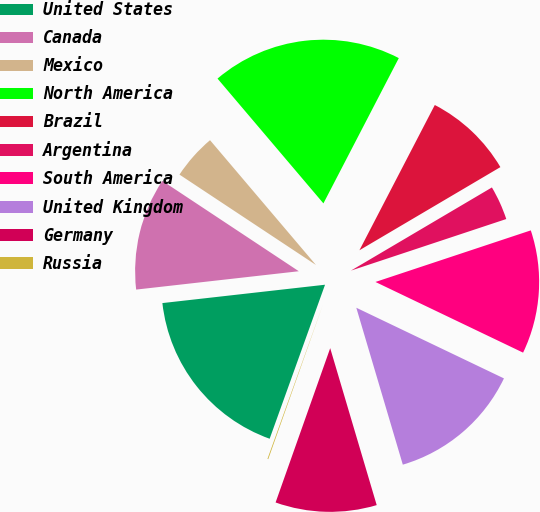Convert chart. <chart><loc_0><loc_0><loc_500><loc_500><pie_chart><fcel>United States<fcel>Canada<fcel>Mexico<fcel>North America<fcel>Brazil<fcel>Argentina<fcel>South America<fcel>United Kingdom<fcel>Germany<fcel>Russia<nl><fcel>17.72%<fcel>11.1%<fcel>4.49%<fcel>18.82%<fcel>8.9%<fcel>3.38%<fcel>12.21%<fcel>13.31%<fcel>10.0%<fcel>0.08%<nl></chart> 